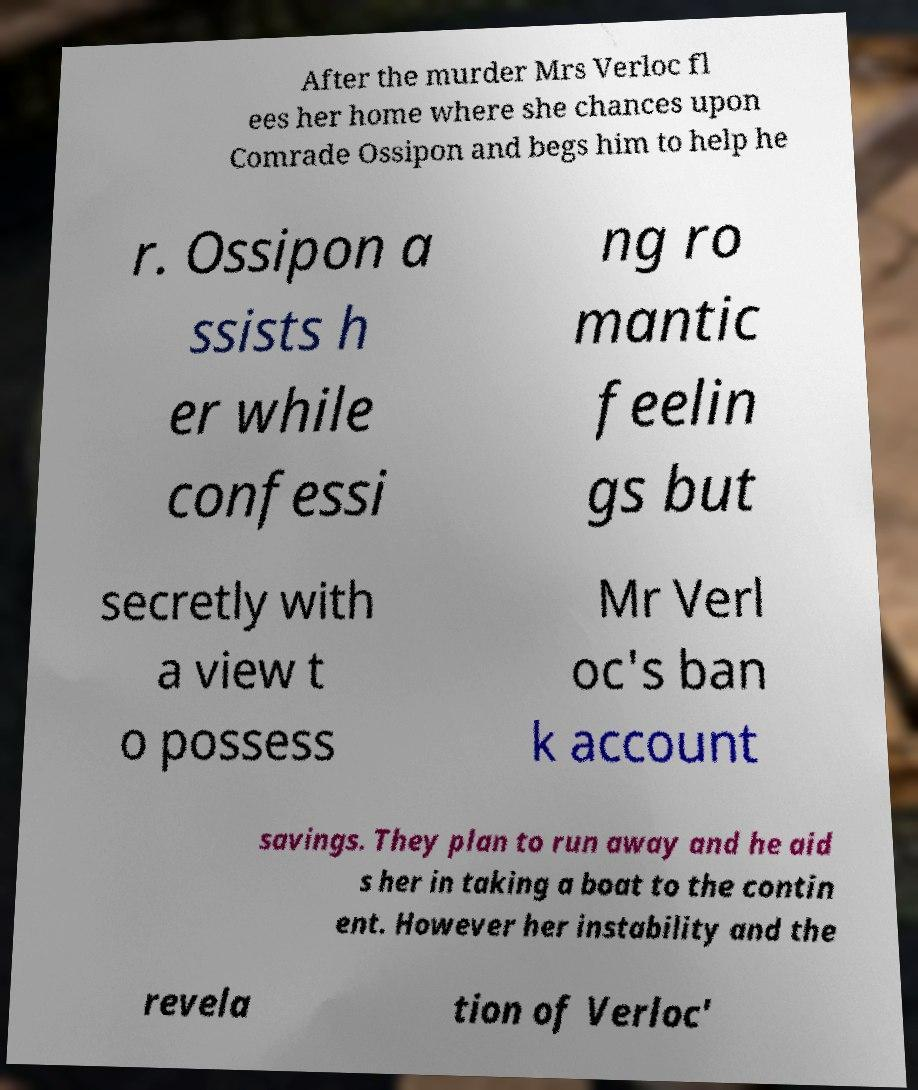For documentation purposes, I need the text within this image transcribed. Could you provide that? After the murder Mrs Verloc fl ees her home where she chances upon Comrade Ossipon and begs him to help he r. Ossipon a ssists h er while confessi ng ro mantic feelin gs but secretly with a view t o possess Mr Verl oc's ban k account savings. They plan to run away and he aid s her in taking a boat to the contin ent. However her instability and the revela tion of Verloc' 